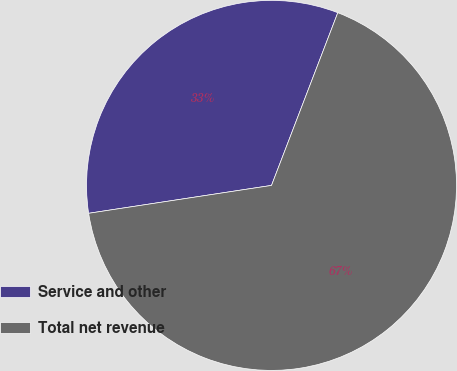Convert chart to OTSL. <chart><loc_0><loc_0><loc_500><loc_500><pie_chart><fcel>Service and other<fcel>Total net revenue<nl><fcel>33.24%<fcel>66.76%<nl></chart> 